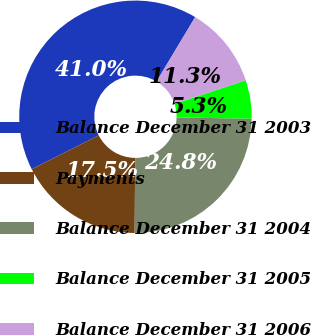Convert chart to OTSL. <chart><loc_0><loc_0><loc_500><loc_500><pie_chart><fcel>Balance December 31 2003<fcel>Payments<fcel>Balance December 31 2004<fcel>Balance December 31 2005<fcel>Balance December 31 2006<nl><fcel>41.04%<fcel>17.45%<fcel>24.84%<fcel>5.35%<fcel>11.32%<nl></chart> 